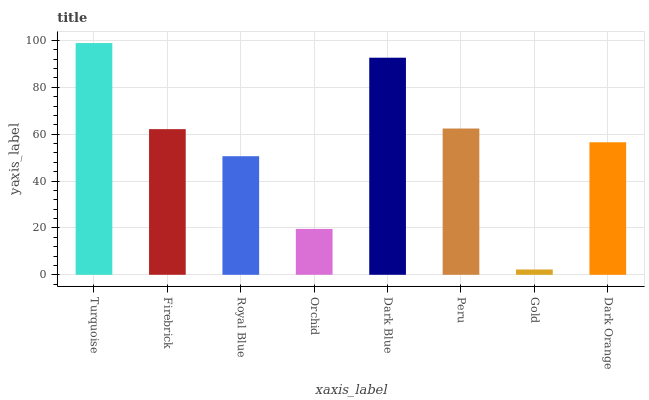Is Gold the minimum?
Answer yes or no. Yes. Is Turquoise the maximum?
Answer yes or no. Yes. Is Firebrick the minimum?
Answer yes or no. No. Is Firebrick the maximum?
Answer yes or no. No. Is Turquoise greater than Firebrick?
Answer yes or no. Yes. Is Firebrick less than Turquoise?
Answer yes or no. Yes. Is Firebrick greater than Turquoise?
Answer yes or no. No. Is Turquoise less than Firebrick?
Answer yes or no. No. Is Firebrick the high median?
Answer yes or no. Yes. Is Dark Orange the low median?
Answer yes or no. Yes. Is Peru the high median?
Answer yes or no. No. Is Gold the low median?
Answer yes or no. No. 